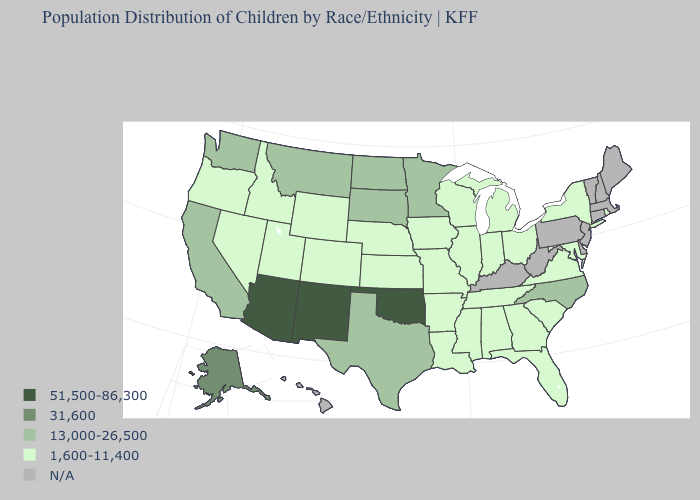What is the value of Maine?
Be succinct. N/A. Which states have the highest value in the USA?
Answer briefly. Arizona, New Mexico, Oklahoma. What is the lowest value in the USA?
Write a very short answer. 1,600-11,400. What is the value of Kansas?
Be succinct. 1,600-11,400. What is the value of California?
Quick response, please. 13,000-26,500. Among the states that border Kansas , does Oklahoma have the lowest value?
Concise answer only. No. What is the lowest value in the MidWest?
Quick response, please. 1,600-11,400. Name the states that have a value in the range 1,600-11,400?
Short answer required. Alabama, Arkansas, Colorado, Florida, Georgia, Idaho, Illinois, Indiana, Iowa, Kansas, Louisiana, Maryland, Michigan, Mississippi, Missouri, Nebraska, Nevada, New York, Ohio, Oregon, Rhode Island, South Carolina, Tennessee, Utah, Virginia, Wisconsin, Wyoming. Name the states that have a value in the range 31,600?
Concise answer only. Alaska. Is the legend a continuous bar?
Answer briefly. No. What is the value of Montana?
Answer briefly. 13,000-26,500. What is the value of Maine?
Give a very brief answer. N/A. 